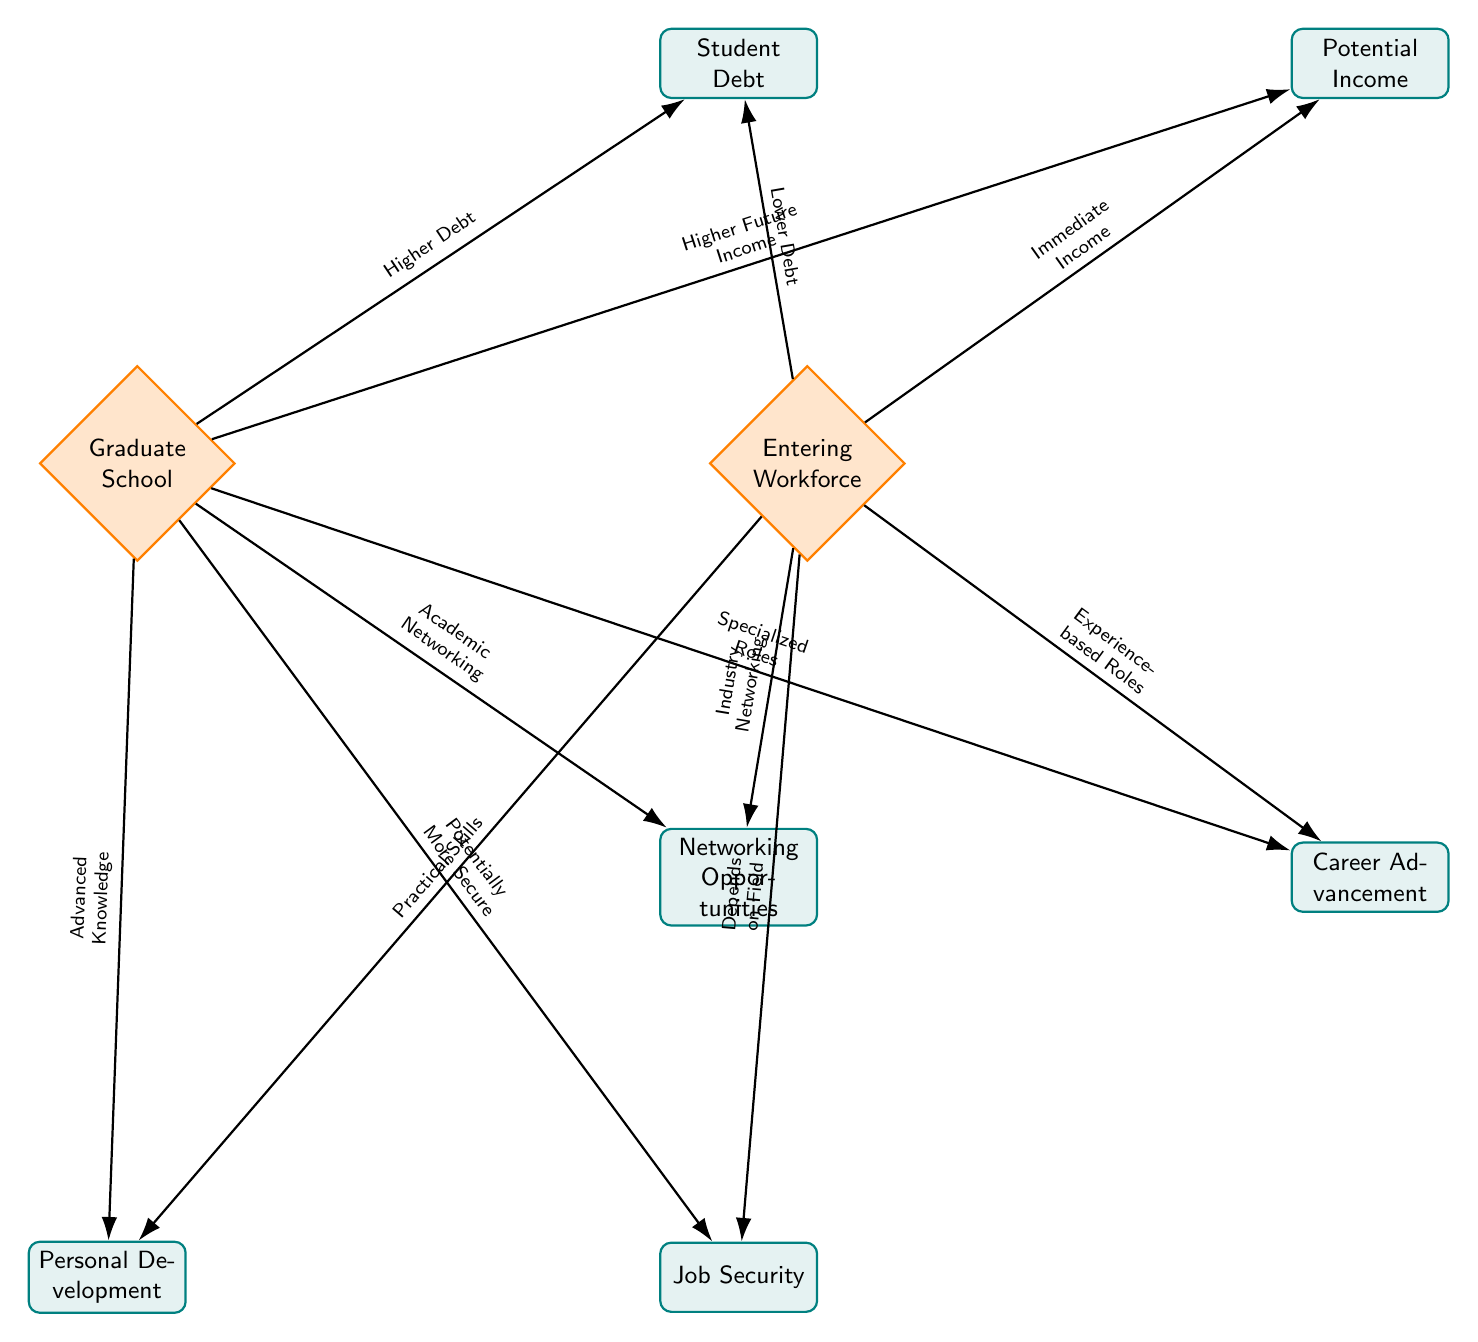What is the main decision node on the left? By observing the diagram, the left node is labeled "Graduate School," which indicates that it represents the option of pursuing further education after graduation.
Answer: Graduate School How many factors are connected to "Entering Workforce"? The diagram shows three factors connected to the "Entering Workforce" node: "Lower Debt," "Immediate Income," and "Industry Networking." Therefore, there are three factors connected to it.
Answer: Three What type of roles are associated with "Career Advancement" in graduate school? The connection from "Graduate School" to "Career Advancement" is labeled "Specialized Roles," suggesting that graduate education can lead to specialized job opportunities in the field.
Answer: Specialized Roles What is the relationship between student debt and entering the workforce? The diagram illustrates that entering the workforce is associated with "Lower Debt," indicating that those who start working immediately after graduation may incur less student debt compared to those who pursue graduate school.
Answer: Lower Debt Which node is linked to "Job Security" as potentially more secure? The "Job Security" factor is linked to the "Graduate School" node, which is connected by the label "Potentially More Secure." This indicates that pursuing further education may lead to better job security.
Answer: Potentially More Secure How do practical skills relate to personal development in the workforce? The connection from the "Entering Workforce" node to the "Personal Development" factor is labeled "Practical Skills," indicating that immediate work experience contributes to practical skill development.
Answer: Practical Skills What connection is made to the "Networking Opportunities" factor from graduate school? The arrow from the "Graduate School" node leads to the "Networking Opportunities" factor, marked "Academic Networking," which means pursuing graduate education provides academic-focused networking possibilities.
Answer: Academic Networking Which node states "Depends on Field" regarding job security? In the diagram, the "Job Security" factor connected to "Entering Workforce" is labeled "Depends on Field," highlighting that job security can vary based on industry or job field when entering the workforce.
Answer: Depends on Field What are the two different outcomes for "Potential Income"? The outcomes for "Potential Income" are connected to both nodes where "Graduate School" leads to "Higher Future Income" and "Entering Workforce" leads to "Immediate Income," indicating different financial trajectories based on the path chosen.
Answer: Higher Future Income and Immediate Income 